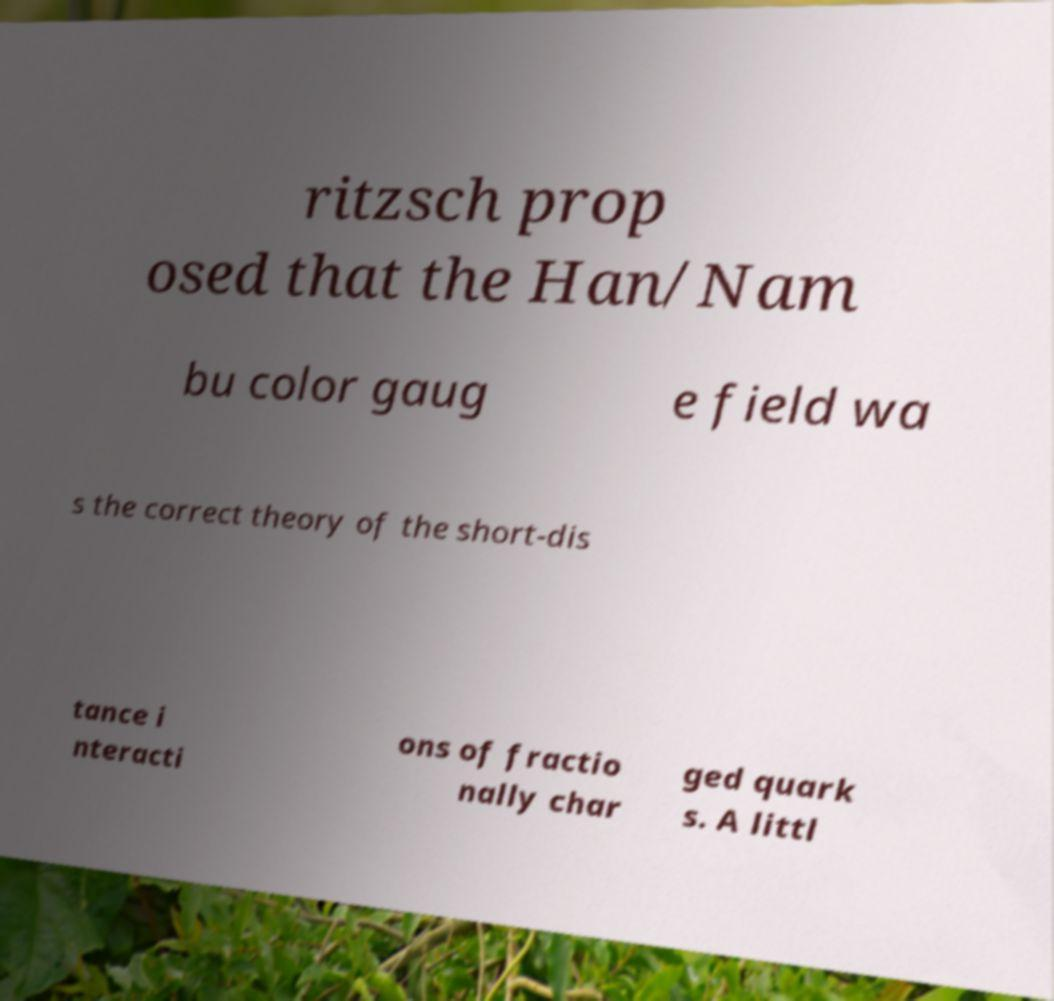Please identify and transcribe the text found in this image. ritzsch prop osed that the Han/Nam bu color gaug e field wa s the correct theory of the short-dis tance i nteracti ons of fractio nally char ged quark s. A littl 